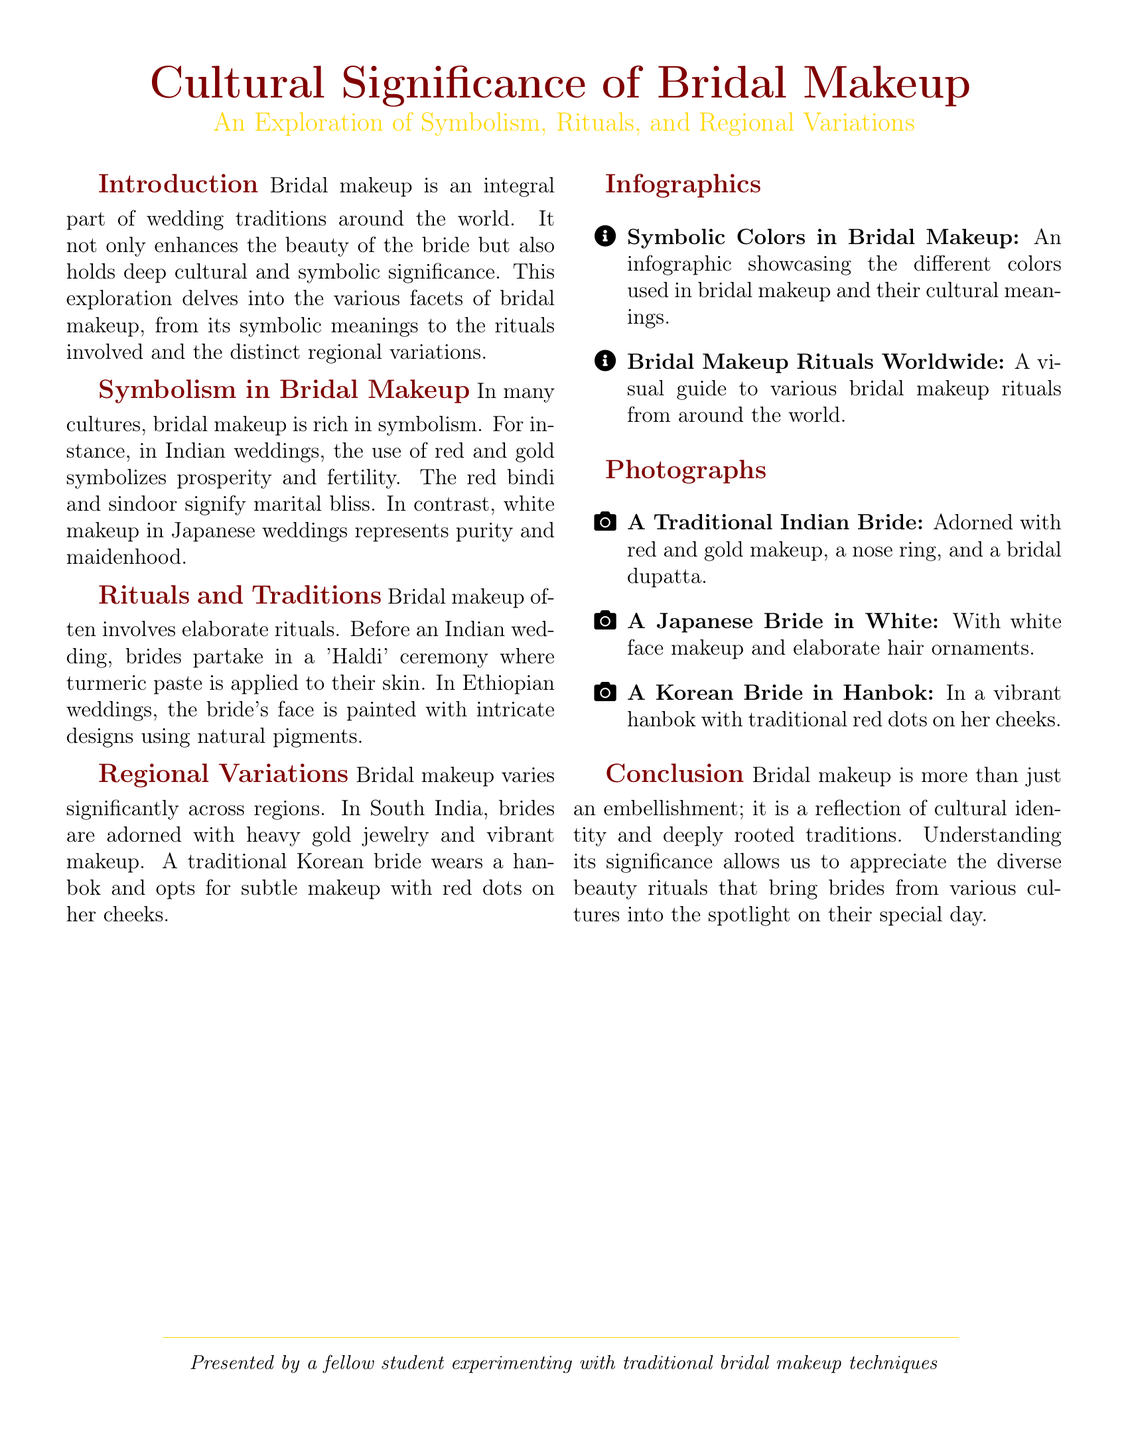What is the primary focus of the document? The document's primary focus is on the cultural significance of bridal makeup, encompassing its symbolism, rituals, and regional variations.
Answer: Cultural significance of bridal makeup What color symbolizes prosperity and fertility in Indian weddings? The document states that red and gold symbolically represent prosperity and fertility in Indian weddings.
Answer: Red and gold What ceremony involves the application of turmeric paste to the bride's skin? The document mentions the 'Haldi' ceremony as the ritual where turmeric paste is applied prior to an Indian wedding.
Answer: Haldi Which country features brides who wear a hanbok? The document indicates that Korean brides typically wear a hanbok during weddings.
Answer: Korea What type of makeup do Japanese brides typically wear? The document specifies that Japanese brides normally wear white makeup representing purity and maidenhood.
Answer: White How many infographics are included in the document? The document lists two infographics related to bridal makeup.
Answer: Two What is one of the significant attributes of South Indian bridal makeup? The document describes heavy gold jewelry as a significant attribute of South Indian bridal makeup.
Answer: Heavy gold jewelry What color is utilized on the cheeks of a traditional Korean bride? The document notes that traditional Korean brides have red dots on their cheeks as part of their makeup.
Answer: Red dots 